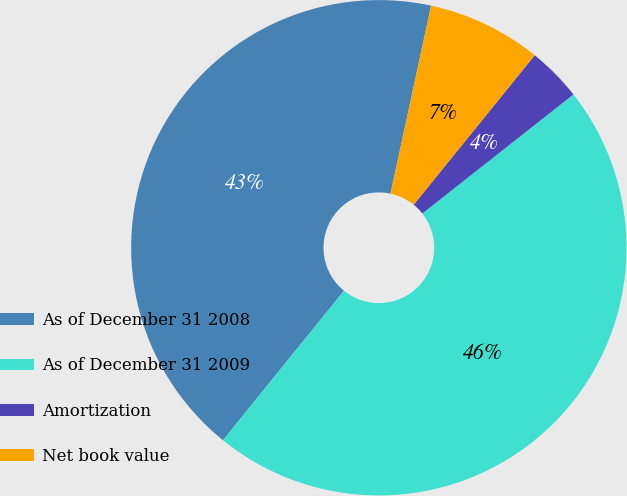Convert chart to OTSL. <chart><loc_0><loc_0><loc_500><loc_500><pie_chart><fcel>As of December 31 2008<fcel>As of December 31 2009<fcel>Amortization<fcel>Net book value<nl><fcel>42.55%<fcel>46.45%<fcel>3.55%<fcel>7.45%<nl></chart> 